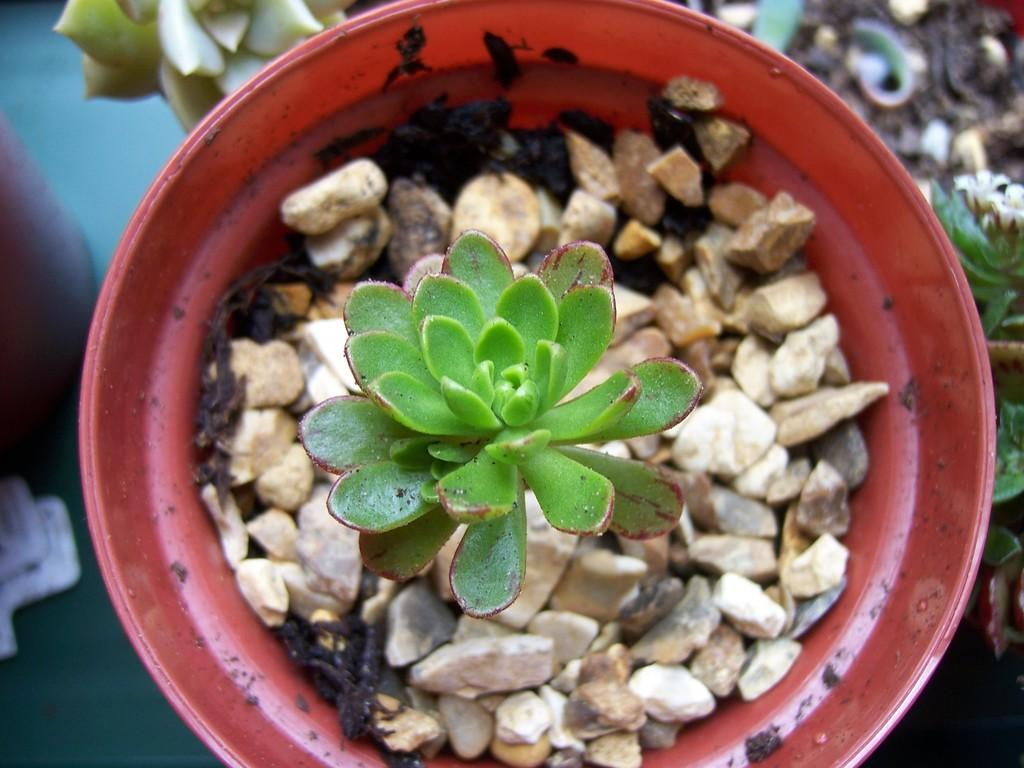What is in the image that can hold a plant? There is a flower pot in the image. What is inside the flower pot? There is a small plant in the flower pot. What else can be found in the flower pot besides the plant? There are stones in the flower pot. Who is the authority figure in the image? There is no authority figure present in the image, as it only contains a flower pot, a small plant, and stones. 